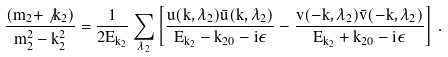<formula> <loc_0><loc_0><loc_500><loc_500>\frac { ( m _ { 2 } + \not { k } _ { 2 } ) } { m _ { 2 } ^ { 2 } - k _ { 2 } ^ { 2 } } = \frac { 1 } { 2 E _ { k _ { 2 } } } \sum _ { \lambda _ { 2 } } \left [ \frac { u ( { k } , \lambda _ { 2 } ) \bar { u } ( { k } , \lambda _ { 2 } ) } { E _ { k _ { 2 } } - k _ { 2 0 } - i \epsilon } - \frac { v ( - { k } , \lambda _ { 2 } ) \bar { v } ( - { k } , \lambda _ { 2 } ) } { E _ { k _ { 2 } } + k _ { 2 0 } - i \epsilon } \right ] \, .</formula> 